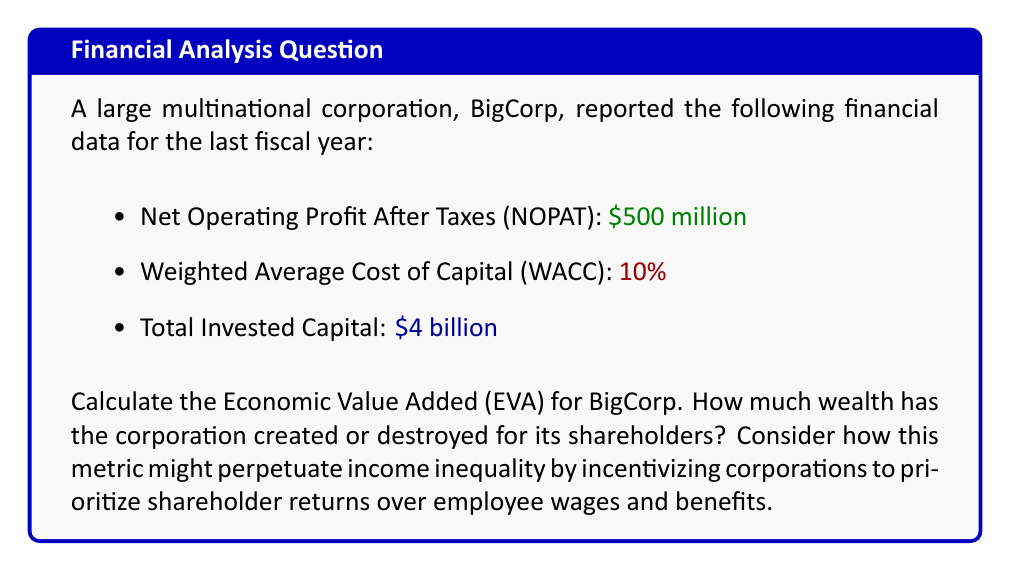What is the answer to this math problem? To calculate the Economic Value Added (EVA), we'll follow these steps:

1) The formula for EVA is:

   $$EVA = NOPAT - (WACC \times \text{Invested Capital})$$

2) We have all the necessary information:
   - NOPAT = $500 million
   - WACC = 10% = 0.10
   - Invested Capital = $4 billion = $4,000 million

3) Let's substitute these values into the formula:

   $$EVA = 500 - (0.10 \times 4,000)$$

4) First, calculate the cost of capital:
   
   $$0.10 \times 4,000 = 400$$

5) Now, subtract this from NOPAT:

   $$EVA = 500 - 400 = 100$$

6) Therefore, the EVA is $100 million.

This positive EVA indicates that BigCorp has created $100 million in wealth for its shareholders above the cost of capital. While this metric is celebrated in corporate finance, it's worth noting that it doesn't account for wealth distribution among stakeholders. The focus on maximizing EVA can lead corporations to prioritize shareholder returns over other considerations like employee wages, benefits, or broader social responsibilities, potentially exacerbating income inequality.
Answer: $100 million 